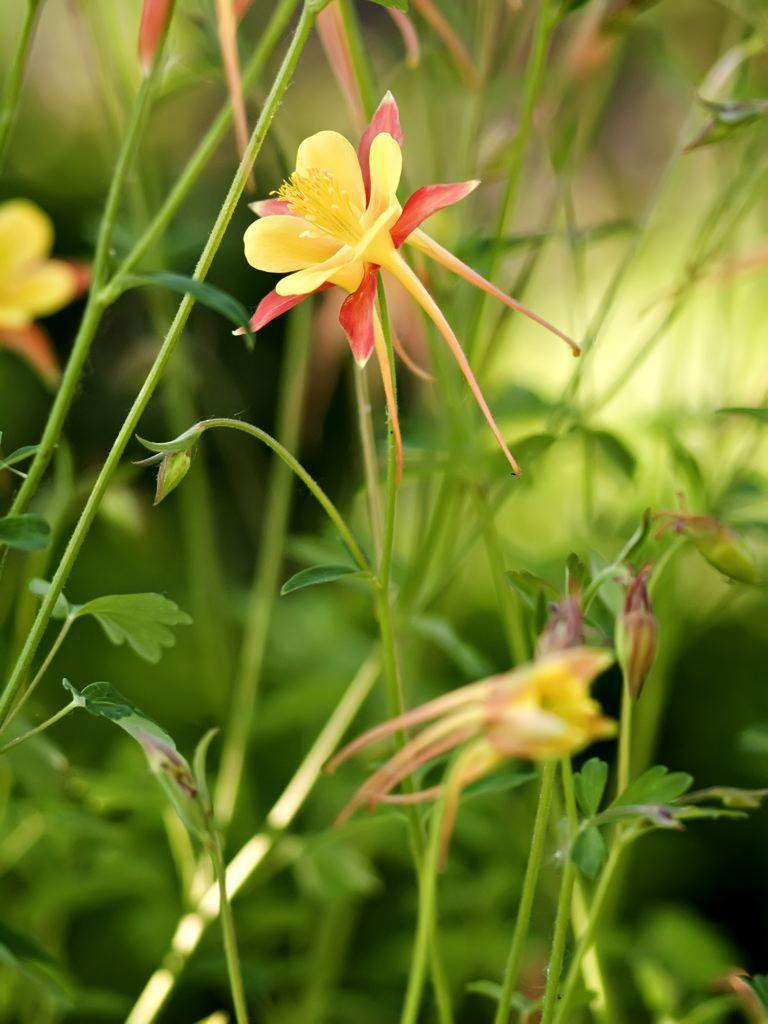What type of plants can be seen in the image? There are flowers in the image. How are the flowers connected to the rest of the plant? The flowers are attached to stems. What can be observed about the background of the image? The backdrop of the image is blurred. How many spiders can be seen spinning webs on the flowers in the image? There are no spiders present in the image, and therefore no spider webs can be observed on the flowers. 